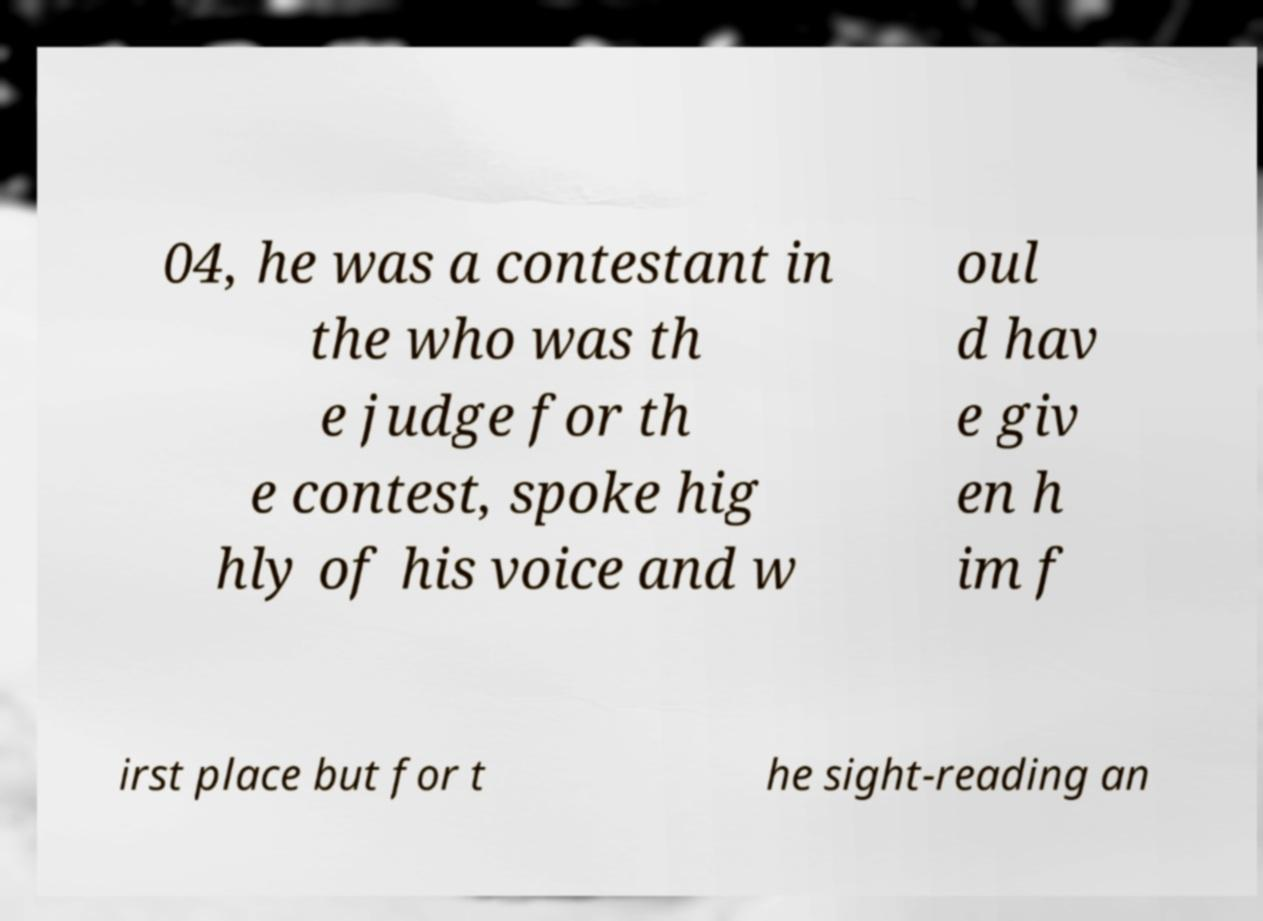Can you read and provide the text displayed in the image?This photo seems to have some interesting text. Can you extract and type it out for me? 04, he was a contestant in the who was th e judge for th e contest, spoke hig hly of his voice and w oul d hav e giv en h im f irst place but for t he sight-reading an 